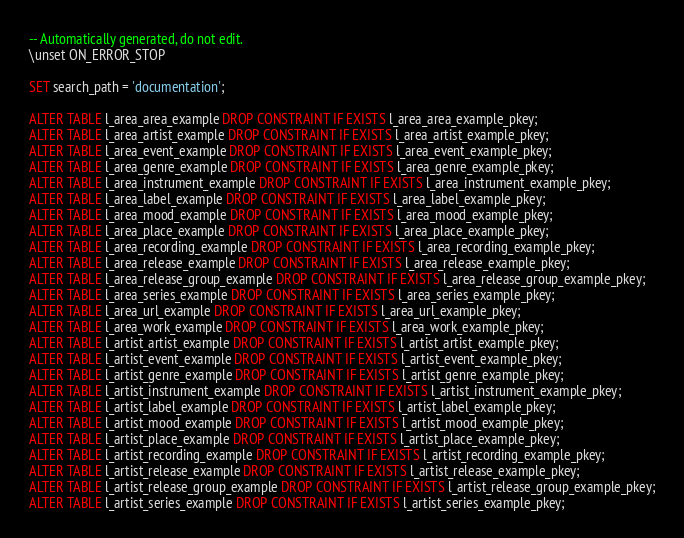Convert code to text. <code><loc_0><loc_0><loc_500><loc_500><_SQL_>-- Automatically generated, do not edit.
\unset ON_ERROR_STOP

SET search_path = 'documentation';

ALTER TABLE l_area_area_example DROP CONSTRAINT IF EXISTS l_area_area_example_pkey;
ALTER TABLE l_area_artist_example DROP CONSTRAINT IF EXISTS l_area_artist_example_pkey;
ALTER TABLE l_area_event_example DROP CONSTRAINT IF EXISTS l_area_event_example_pkey;
ALTER TABLE l_area_genre_example DROP CONSTRAINT IF EXISTS l_area_genre_example_pkey;
ALTER TABLE l_area_instrument_example DROP CONSTRAINT IF EXISTS l_area_instrument_example_pkey;
ALTER TABLE l_area_label_example DROP CONSTRAINT IF EXISTS l_area_label_example_pkey;
ALTER TABLE l_area_mood_example DROP CONSTRAINT IF EXISTS l_area_mood_example_pkey;
ALTER TABLE l_area_place_example DROP CONSTRAINT IF EXISTS l_area_place_example_pkey;
ALTER TABLE l_area_recording_example DROP CONSTRAINT IF EXISTS l_area_recording_example_pkey;
ALTER TABLE l_area_release_example DROP CONSTRAINT IF EXISTS l_area_release_example_pkey;
ALTER TABLE l_area_release_group_example DROP CONSTRAINT IF EXISTS l_area_release_group_example_pkey;
ALTER TABLE l_area_series_example DROP CONSTRAINT IF EXISTS l_area_series_example_pkey;
ALTER TABLE l_area_url_example DROP CONSTRAINT IF EXISTS l_area_url_example_pkey;
ALTER TABLE l_area_work_example DROP CONSTRAINT IF EXISTS l_area_work_example_pkey;
ALTER TABLE l_artist_artist_example DROP CONSTRAINT IF EXISTS l_artist_artist_example_pkey;
ALTER TABLE l_artist_event_example DROP CONSTRAINT IF EXISTS l_artist_event_example_pkey;
ALTER TABLE l_artist_genre_example DROP CONSTRAINT IF EXISTS l_artist_genre_example_pkey;
ALTER TABLE l_artist_instrument_example DROP CONSTRAINT IF EXISTS l_artist_instrument_example_pkey;
ALTER TABLE l_artist_label_example DROP CONSTRAINT IF EXISTS l_artist_label_example_pkey;
ALTER TABLE l_artist_mood_example DROP CONSTRAINT IF EXISTS l_artist_mood_example_pkey;
ALTER TABLE l_artist_place_example DROP CONSTRAINT IF EXISTS l_artist_place_example_pkey;
ALTER TABLE l_artist_recording_example DROP CONSTRAINT IF EXISTS l_artist_recording_example_pkey;
ALTER TABLE l_artist_release_example DROP CONSTRAINT IF EXISTS l_artist_release_example_pkey;
ALTER TABLE l_artist_release_group_example DROP CONSTRAINT IF EXISTS l_artist_release_group_example_pkey;
ALTER TABLE l_artist_series_example DROP CONSTRAINT IF EXISTS l_artist_series_example_pkey;</code> 